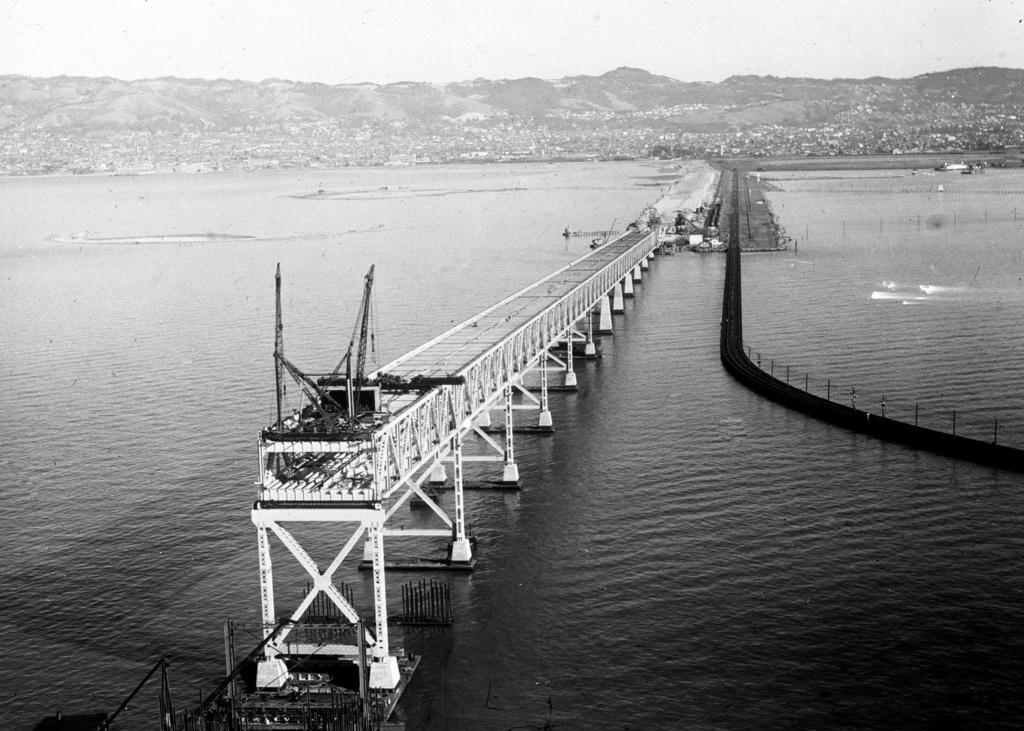What is the color scheme of the image? The image is black and white. What is the main subject of the image? There is a bridge in the image. What is the bridge situated over? The bridge is over water. What can be seen in the background of the image? There are hills and the sky visible in the background of the image. What type of net can be seen hanging from the bridge in the image? There is no net visible in the image; it only features a bridge over water with hills and the sky in the background. Can you describe the bee's behavior on the bridge in the image? There are no bees present in the image; it only features a bridge over water with hills and the sky in the background. 